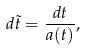<formula> <loc_0><loc_0><loc_500><loc_500>d \tilde { t } = \frac { d t } { a ( t ) } ,</formula> 